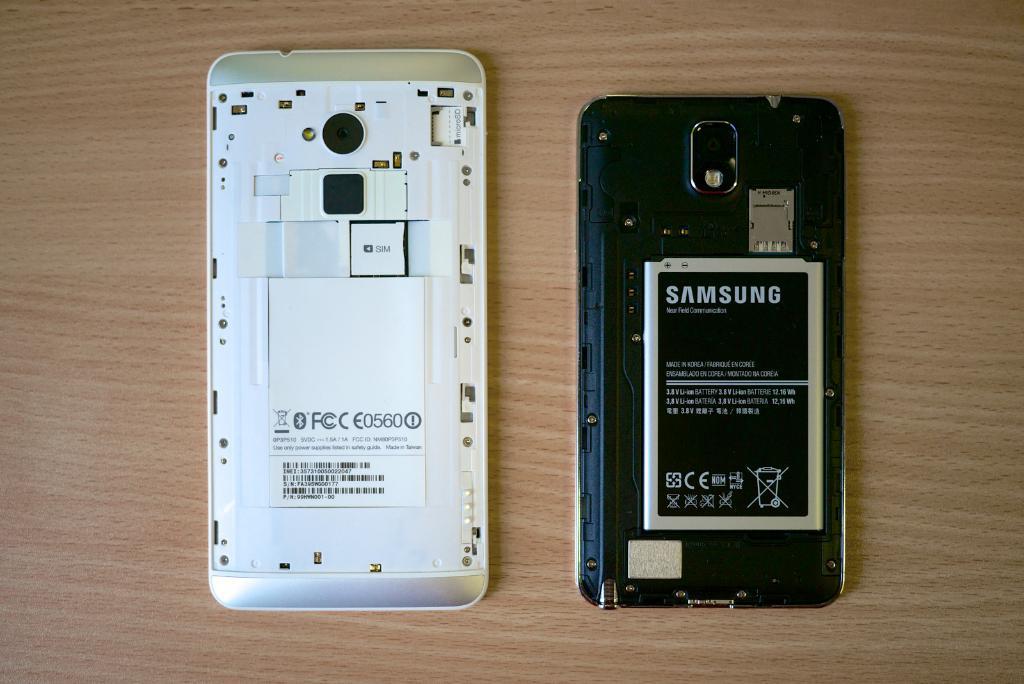What samsung battery is that?
Provide a succinct answer. E0560. Who manufactured the battery?
Your response must be concise. Samsung. 